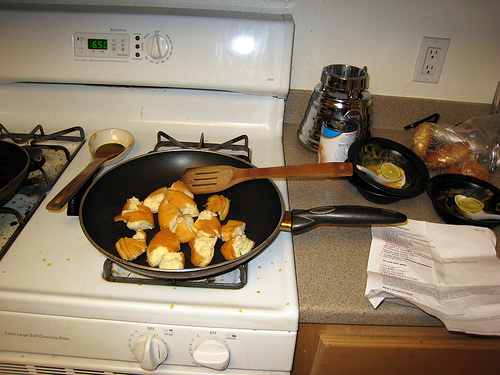<image>
Can you confirm if the food is on the pan? Yes. Looking at the image, I can see the food is positioned on top of the pan, with the pan providing support. 